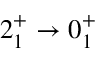Convert formula to latex. <formula><loc_0><loc_0><loc_500><loc_500>2 _ { 1 } ^ { + } \rightarrow 0 _ { 1 } ^ { + }</formula> 